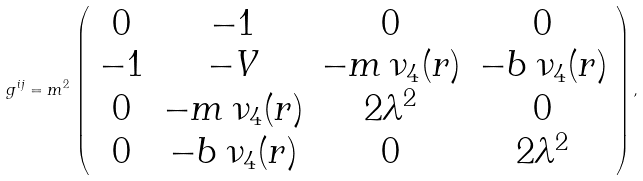<formula> <loc_0><loc_0><loc_500><loc_500>g ^ { i j } = m ^ { 2 } \, \left ( \begin{array} { c c c c } 0 & - 1 & 0 & 0 \\ - 1 & - V & - m \, \nu _ { 4 } ( r ) & - b \, \nu _ { 4 } ( r ) \\ 0 & - m \, \nu _ { 4 } ( r ) & 2 \lambda ^ { 2 } & 0 \\ 0 & - b \, \nu _ { 4 } ( r ) & 0 & 2 \lambda ^ { 2 } \end{array} \right ) ,</formula> 